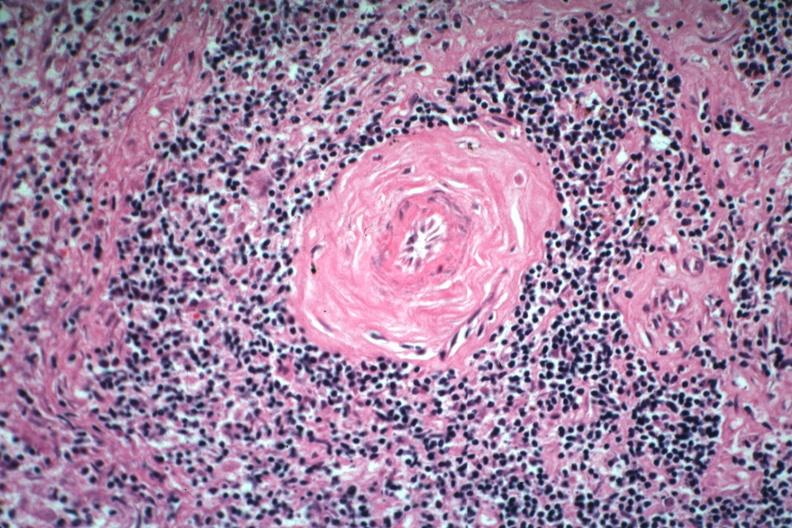what is present?
Answer the question using a single word or phrase. Hematologic 